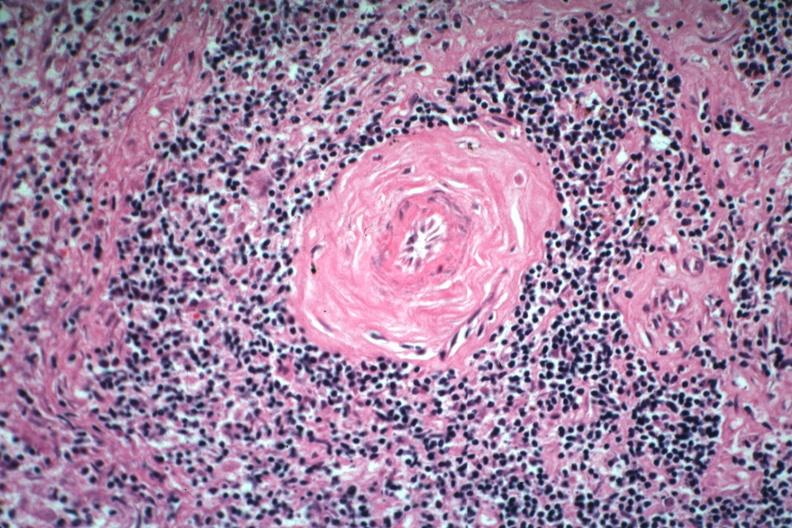what is present?
Answer the question using a single word or phrase. Hematologic 